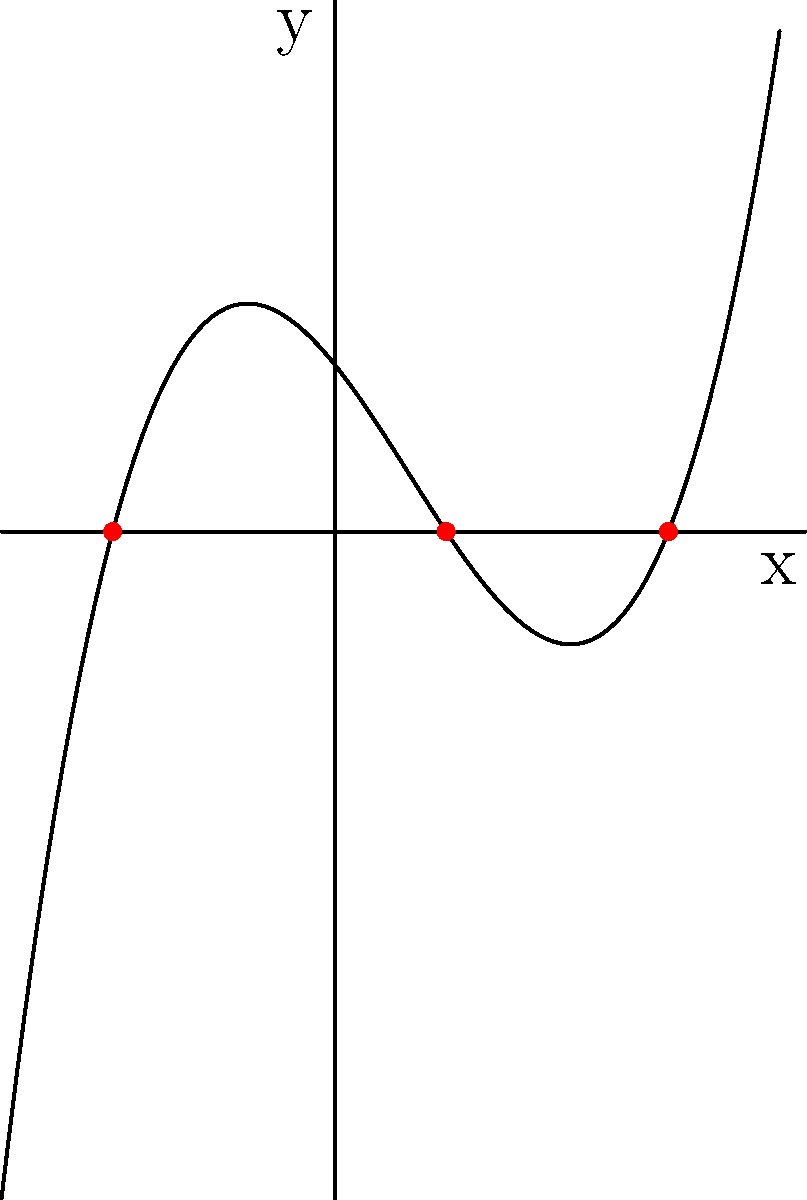As an editor collaborating on a technology history book, you're reviewing a chapter on early computer algorithms. The author mentions polynomial functions and their roots. Given the graph of the polynomial function $f(x) = 0.25(x+2)(x-1)(x-3)$, determine its roots and explain their significance in the context of computer algorithms. To determine the roots of the polynomial function from its graph, we need to follow these steps:

1. Identify the x-intercepts: The roots of a polynomial function are the x-coordinates where the graph crosses the x-axis (y = 0).

2. From the graph, we can see three x-intercepts, marked by red dots:
   a. x = -2
   b. x = 1
   c. x = 3

3. These x-intercepts correspond to the roots of the polynomial function.

4. We can verify this by factoring the given function:
   $f(x) = 0.25(x+2)(x-1)(x-3)$

   When any of these factors equals zero, the entire function equals zero:
   - (x+2) = 0 when x = -2
   - (x-1) = 0 when x = 1
   - (x-3) = 0 when x = 3

5. Significance in computer algorithms:
   - Roots are crucial in many numerical methods and optimization algorithms.
   - They represent solutions to equations, which is fundamental in various computational problems.
   - Understanding roots helps in analyzing algorithm convergence and stability.
   - In early computer history, finding roots efficiently was a significant challenge that drove the development of numerical methods.
Answer: The roots are x = -2, 1, and 3, representing solutions in numerical algorithms. 